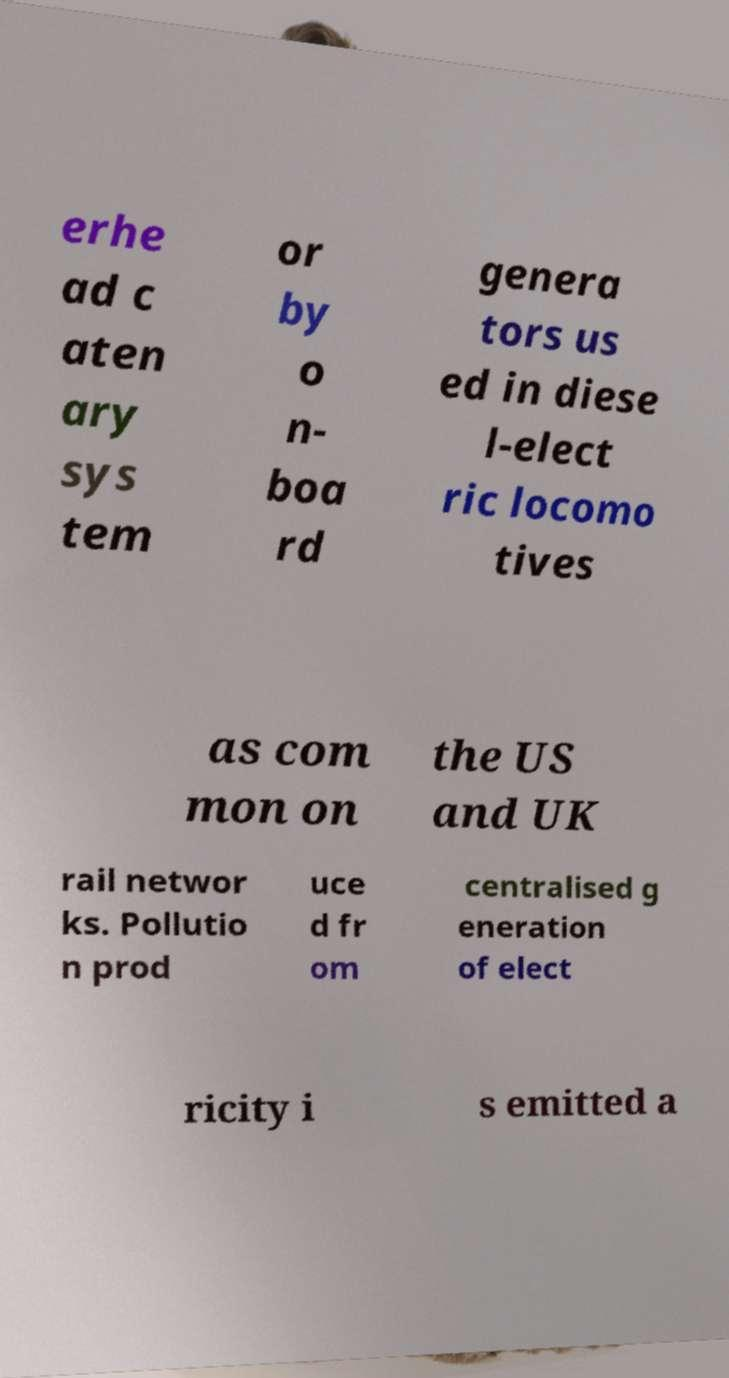Could you assist in decoding the text presented in this image and type it out clearly? erhe ad c aten ary sys tem or by o n- boa rd genera tors us ed in diese l-elect ric locomo tives as com mon on the US and UK rail networ ks. Pollutio n prod uce d fr om centralised g eneration of elect ricity i s emitted a 